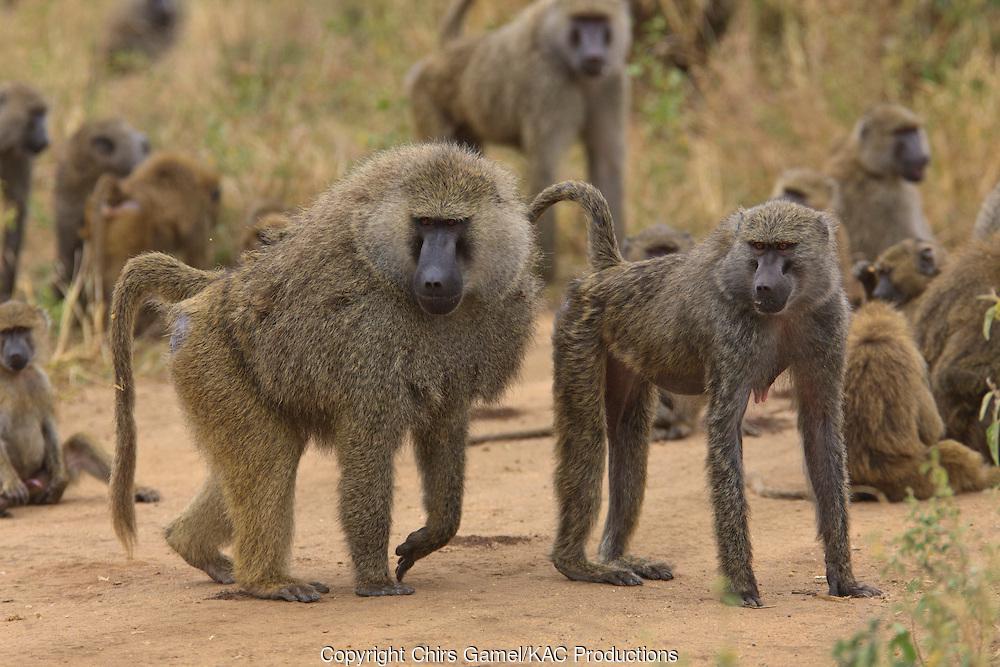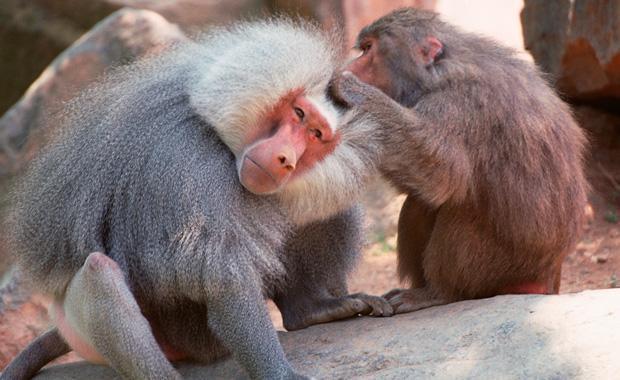The first image is the image on the left, the second image is the image on the right. Evaluate the accuracy of this statement regarding the images: "The right image features two adult baboons stting with a small baby baboon.". Is it true? Answer yes or no. No. 